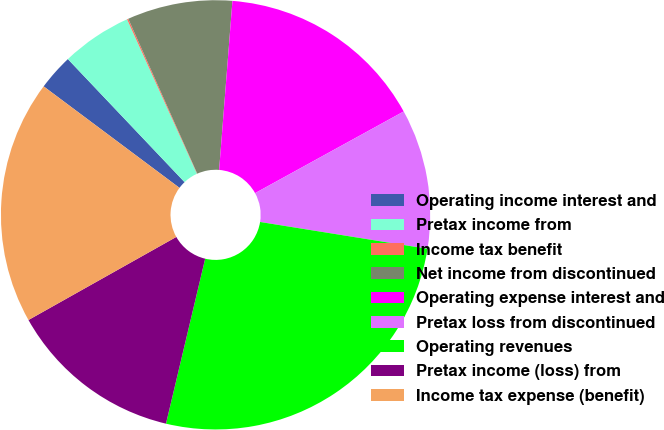<chart> <loc_0><loc_0><loc_500><loc_500><pie_chart><fcel>Operating income interest and<fcel>Pretax income from<fcel>Income tax benefit<fcel>Net income from discontinued<fcel>Operating expense interest and<fcel>Pretax loss from discontinued<fcel>Operating revenues<fcel>Pretax income (loss) from<fcel>Income tax expense (benefit)<nl><fcel>2.71%<fcel>5.31%<fcel>0.1%<fcel>7.92%<fcel>15.75%<fcel>10.53%<fcel>26.18%<fcel>13.14%<fcel>18.36%<nl></chart> 